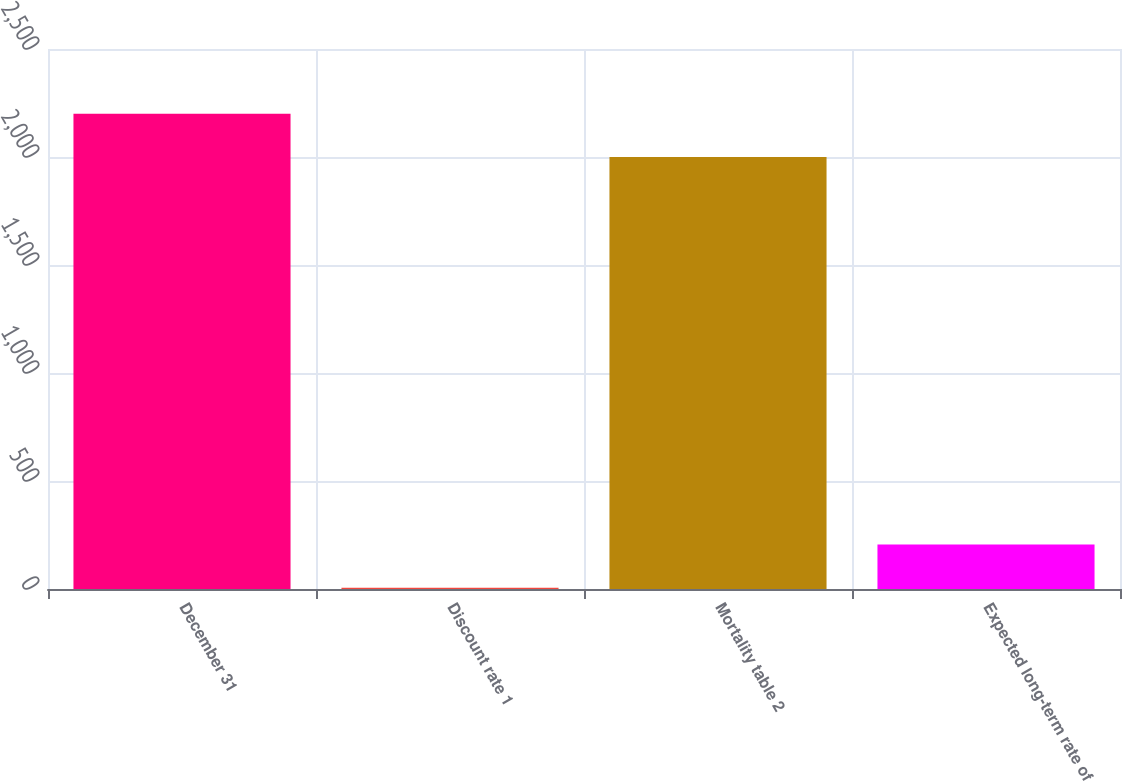Convert chart. <chart><loc_0><loc_0><loc_500><loc_500><bar_chart><fcel>December 31<fcel>Discount rate 1<fcel>Mortality table 2<fcel>Expected long-term rate of<nl><fcel>2200.44<fcel>5.6<fcel>2000<fcel>206.04<nl></chart> 